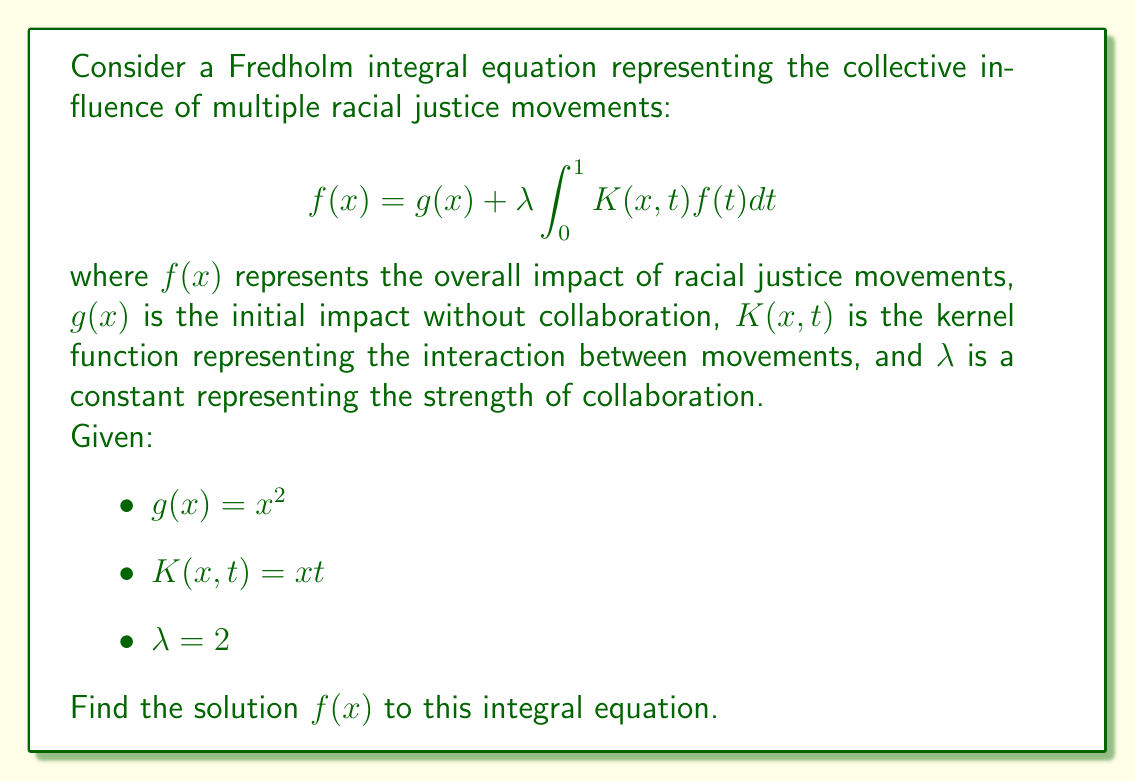What is the answer to this math problem? To solve this Fredholm integral equation, we'll follow these steps:

1) First, we assume a solution of the form:
   $$f(x) = ax^2 + bx$$
   where $a$ and $b$ are constants to be determined.

2) Substitute this into the right-hand side of the equation:
   $$g(x) + \lambda \int_0^1 K(x,t)f(t)dt = x^2 + 2 \int_0^1 xt(at^2 + bt)dt$$

3) Evaluate the integral:
   $$x^2 + 2x \int_0^1 (at^3 + bt^2)dt = x^2 + 2x(\frac{a}{4} + \frac{b}{3})$$

4) Simplify:
   $$x^2 + \frac{ax}{2} + \frac{2bx}{3}$$

5) This should equal our assumed solution $f(x) = ax^2 + bx$. Comparing coefficients:
   $$ax^2 + bx = x^2 + \frac{ax}{2} + \frac{2bx}{3}$$

6) Equating coefficients of $x^2$ and $x$:
   $$a = 1$$
   $$b = \frac{a}{2} + \frac{2b}{3}$$

7) Solve for $b$:
   $$b = \frac{1}{2} + \frac{2b}{3}$$
   $$3b = \frac{3}{2} + 2b$$
   $$b = \frac{3}{2}$$

8) Therefore, the solution is:
   $$f(x) = x^2 + \frac{3}{2}x$$
Answer: $f(x) = x^2 + \frac{3}{2}x$ 